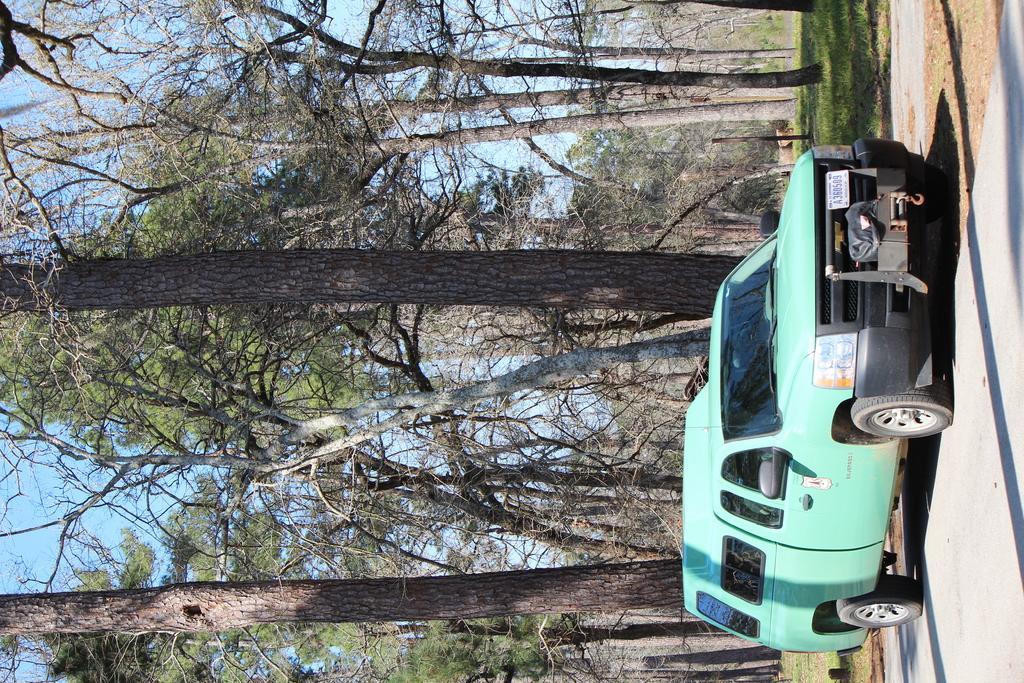Can you describe this image briefly? In this image we can see a motor vehicle on the road, trees, ground and sky. 